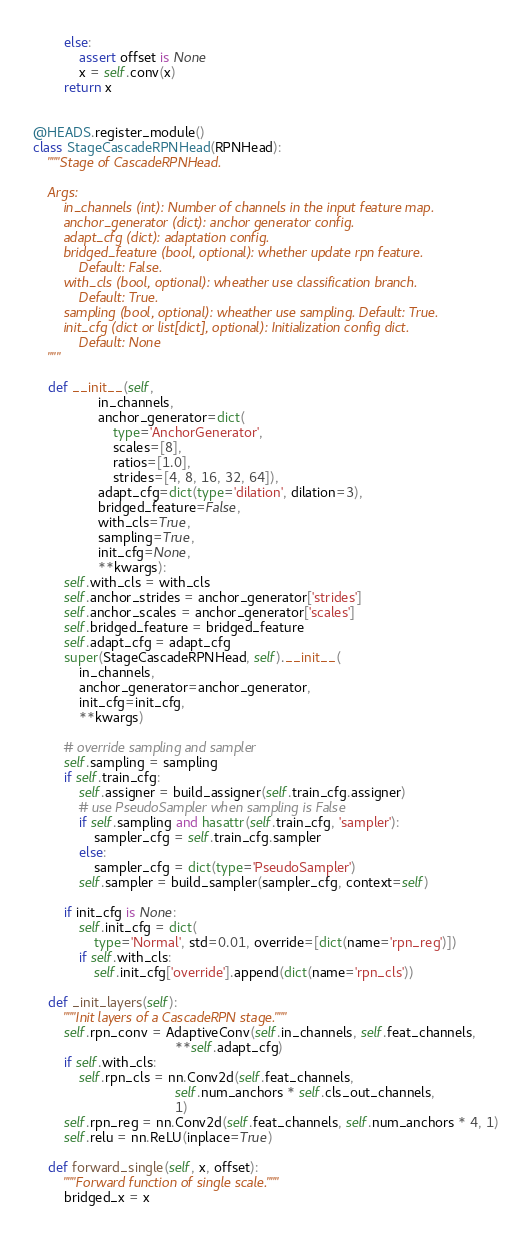Convert code to text. <code><loc_0><loc_0><loc_500><loc_500><_Python_>        else:
            assert offset is None
            x = self.conv(x)
        return x


@HEADS.register_module()
class StageCascadeRPNHead(RPNHead):
    """Stage of CascadeRPNHead.

    Args:
        in_channels (int): Number of channels in the input feature map.
        anchor_generator (dict): anchor generator config.
        adapt_cfg (dict): adaptation config.
        bridged_feature (bool, optional): whether update rpn feature.
            Default: False.
        with_cls (bool, optional): wheather use classification branch.
            Default: True.
        sampling (bool, optional): wheather use sampling. Default: True.
        init_cfg (dict or list[dict], optional): Initialization config dict.
            Default: None
    """

    def __init__(self,
                 in_channels,
                 anchor_generator=dict(
                     type='AnchorGenerator',
                     scales=[8],
                     ratios=[1.0],
                     strides=[4, 8, 16, 32, 64]),
                 adapt_cfg=dict(type='dilation', dilation=3),
                 bridged_feature=False,
                 with_cls=True,
                 sampling=True,
                 init_cfg=None,
                 **kwargs):
        self.with_cls = with_cls
        self.anchor_strides = anchor_generator['strides']
        self.anchor_scales = anchor_generator['scales']
        self.bridged_feature = bridged_feature
        self.adapt_cfg = adapt_cfg
        super(StageCascadeRPNHead, self).__init__(
            in_channels,
            anchor_generator=anchor_generator,
            init_cfg=init_cfg,
            **kwargs)

        # override sampling and sampler
        self.sampling = sampling
        if self.train_cfg:
            self.assigner = build_assigner(self.train_cfg.assigner)
            # use PseudoSampler when sampling is False
            if self.sampling and hasattr(self.train_cfg, 'sampler'):
                sampler_cfg = self.train_cfg.sampler
            else:
                sampler_cfg = dict(type='PseudoSampler')
            self.sampler = build_sampler(sampler_cfg, context=self)

        if init_cfg is None:
            self.init_cfg = dict(
                type='Normal', std=0.01, override=[dict(name='rpn_reg')])
            if self.with_cls:
                self.init_cfg['override'].append(dict(name='rpn_cls'))

    def _init_layers(self):
        """Init layers of a CascadeRPN stage."""
        self.rpn_conv = AdaptiveConv(self.in_channels, self.feat_channels,
                                     **self.adapt_cfg)
        if self.with_cls:
            self.rpn_cls = nn.Conv2d(self.feat_channels,
                                     self.num_anchors * self.cls_out_channels,
                                     1)
        self.rpn_reg = nn.Conv2d(self.feat_channels, self.num_anchors * 4, 1)
        self.relu = nn.ReLU(inplace=True)

    def forward_single(self, x, offset):
        """Forward function of single scale."""
        bridged_x = x</code> 